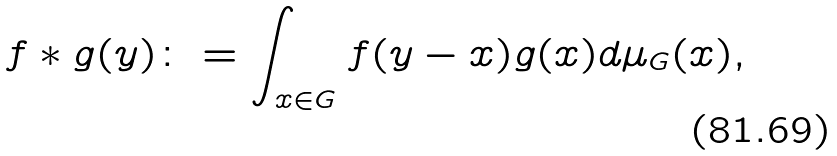Convert formula to latex. <formula><loc_0><loc_0><loc_500><loc_500>f \ast g ( y ) \colon = \int _ { x \in G } { f ( y - x ) g ( x ) d \mu _ { G } ( x ) } ,</formula> 